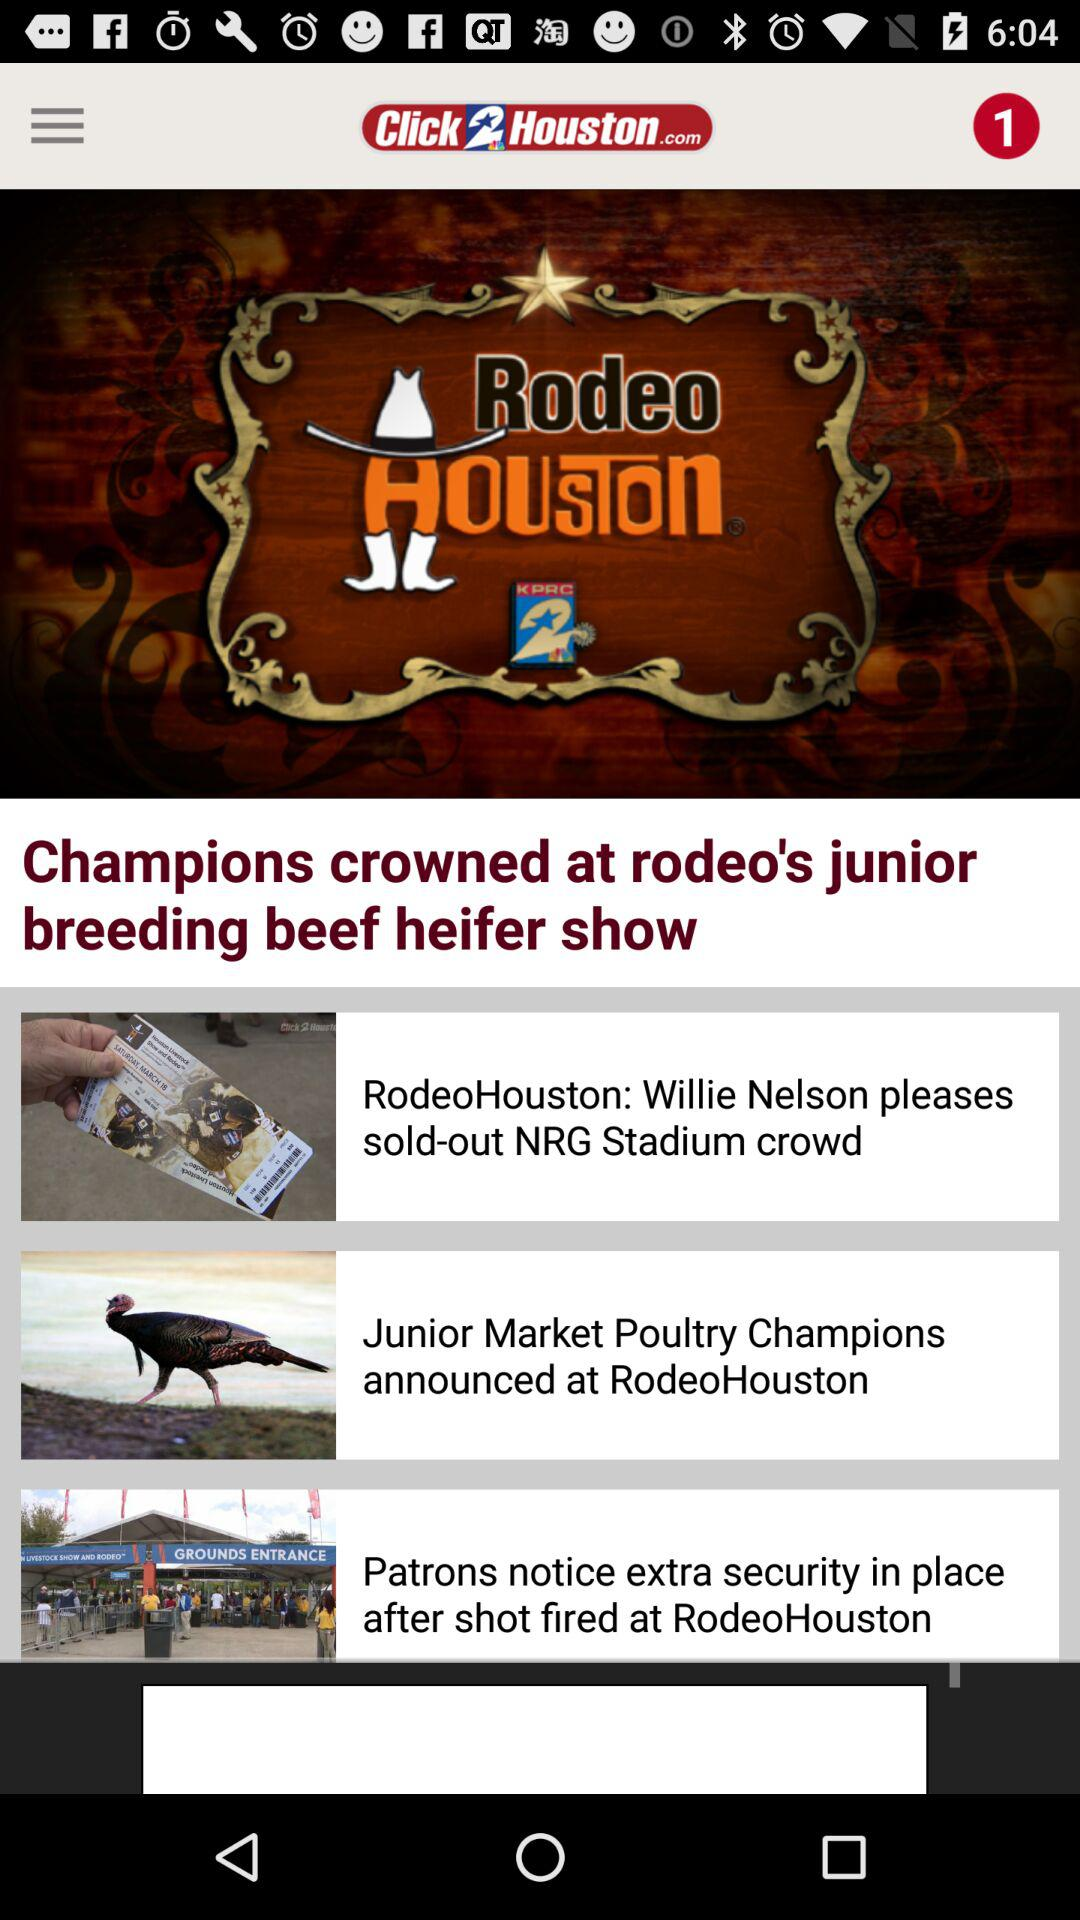How many unread notifications are on the screen? There is 1 unread notification. 